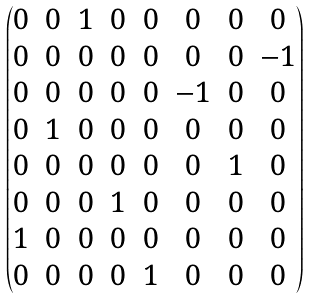Convert formula to latex. <formula><loc_0><loc_0><loc_500><loc_500>\begin{pmatrix} 0 & 0 & 1 & 0 & 0 & 0 & 0 & 0 \\ 0 & 0 & 0 & 0 & 0 & 0 & 0 & - 1 \\ 0 & 0 & 0 & 0 & 0 & - 1 & 0 & 0 \\ 0 & 1 & 0 & 0 & 0 & 0 & 0 & 0 \\ 0 & 0 & 0 & 0 & 0 & 0 & 1 & 0 \\ 0 & 0 & 0 & 1 & 0 & 0 & 0 & 0 \\ 1 & 0 & 0 & 0 & 0 & 0 & 0 & 0 \\ 0 & 0 & 0 & 0 & 1 & 0 & 0 & 0 \end{pmatrix}</formula> 